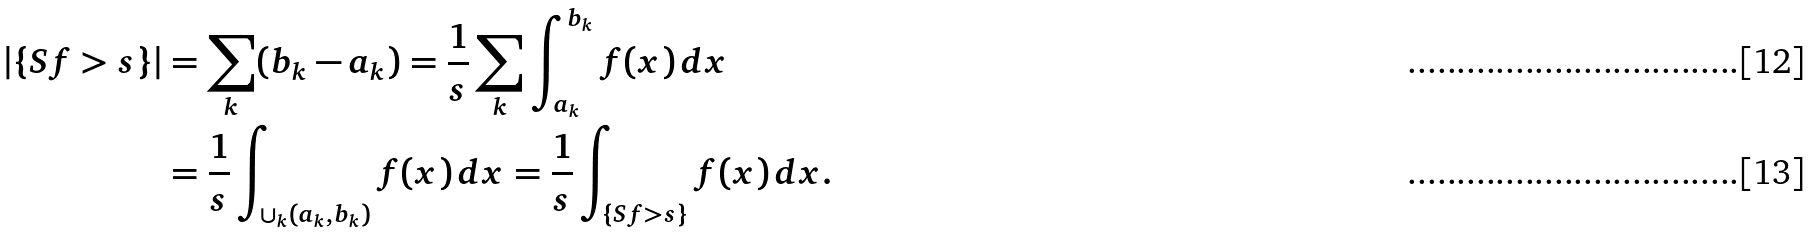Convert formula to latex. <formula><loc_0><loc_0><loc_500><loc_500>| \{ S f > s \} | & = \sum _ { k } ( b _ { k } - a _ { k } ) = \frac { 1 } { s } \sum _ { k } \int _ { a _ { k } } ^ { b _ { k } } f ( x ) \, d x \\ & = \frac { 1 } { s } \int _ { \cup _ { k } ( a _ { k } , b _ { k } ) } f ( x ) \, d x = \frac { 1 } { s } \int _ { \{ S f > s \} } f ( x ) \, d x .</formula> 